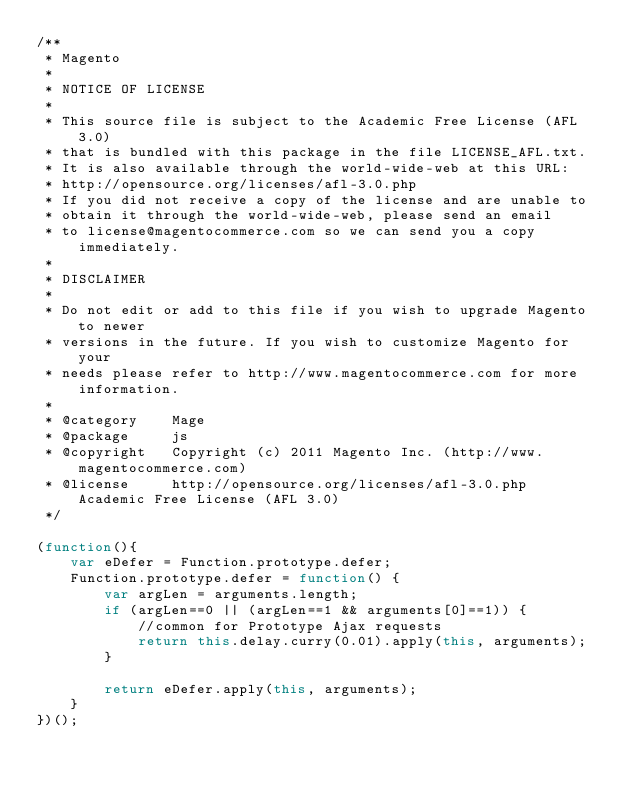<code> <loc_0><loc_0><loc_500><loc_500><_JavaScript_>/**
 * Magento
 *
 * NOTICE OF LICENSE
 *
 * This source file is subject to the Academic Free License (AFL 3.0)
 * that is bundled with this package in the file LICENSE_AFL.txt.
 * It is also available through the world-wide-web at this URL:
 * http://opensource.org/licenses/afl-3.0.php
 * If you did not receive a copy of the license and are unable to
 * obtain it through the world-wide-web, please send an email
 * to license@magentocommerce.com so we can send you a copy immediately.
 *
 * DISCLAIMER
 *
 * Do not edit or add to this file if you wish to upgrade Magento to newer
 * versions in the future. If you wish to customize Magento for your
 * needs please refer to http://www.magentocommerce.com for more information.
 *
 * @category    Mage
 * @package     js
 * @copyright   Copyright (c) 2011 Magento Inc. (http://www.magentocommerce.com)
 * @license     http://opensource.org/licenses/afl-3.0.php  Academic Free License (AFL 3.0)
 */

(function(){
    var eDefer = Function.prototype.defer;
    Function.prototype.defer = function() {
        var argLen = arguments.length;
        if (argLen==0 || (argLen==1 && arguments[0]==1)) {
            //common for Prototype Ajax requests
            return this.delay.curry(0.01).apply(this, arguments);
        }

        return eDefer.apply(this, arguments);
    }
})();</code> 